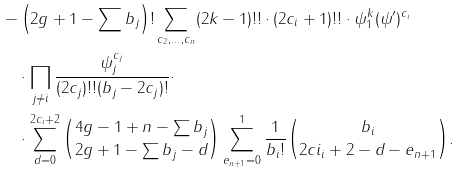Convert formula to latex. <formula><loc_0><loc_0><loc_500><loc_500>- & \left ( 2 g + 1 - \sum b _ { j } \right ) ! \sum _ { c _ { 2 } , \dots , c _ { n } } ( 2 k - 1 ) ! ! \cdot ( 2 c _ { i } + 1 ) ! ! \cdot \psi _ { 1 } ^ { k } ( \psi ^ { \prime } ) ^ { c _ { i } } \\ & \cdot \prod _ { j \neq i } \frac { \psi _ { j } ^ { c _ { j } } } { ( 2 c _ { j } ) ! ! ( b _ { j } - 2 c _ { j } ) ! } \cdot \\ & \cdot \sum _ { d = 0 } ^ { 2 c _ { i } + 2 } { 4 g - 1 + n - \sum b _ { j } \choose 2 g + 1 - \sum b _ { j } - d } \sum _ { e _ { n + 1 } = 0 } ^ { 1 } \frac { 1 } { b _ { i } ! } { b _ { i } \choose 2 c i _ { i } + 2 - d - e _ { n + 1 } } .</formula> 